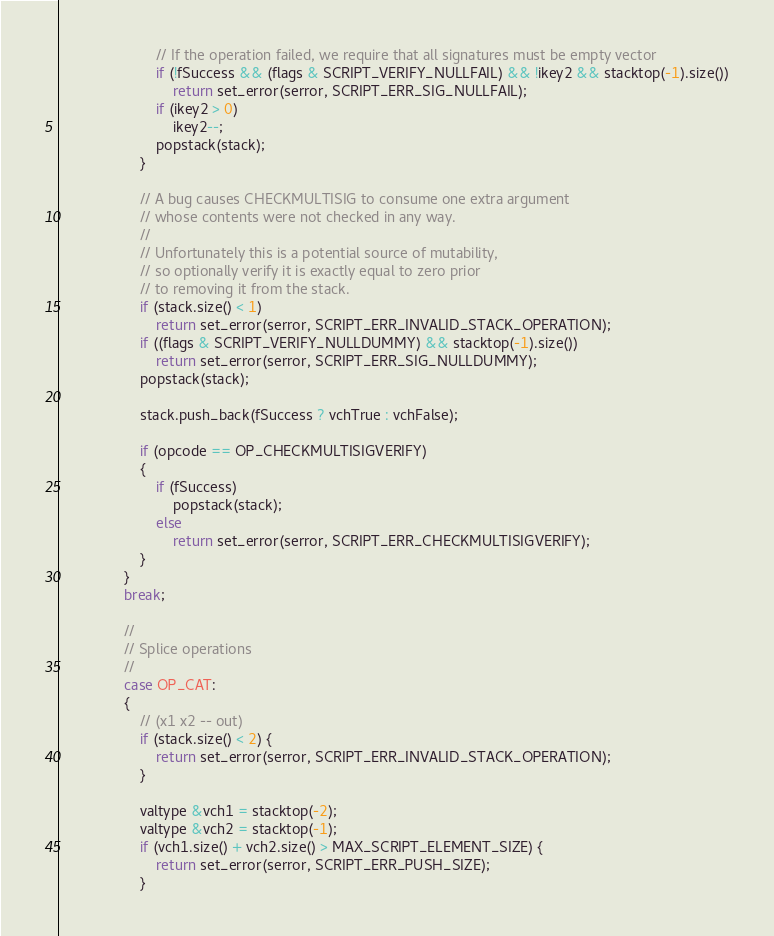Convert code to text. <code><loc_0><loc_0><loc_500><loc_500><_C++_>                        // If the operation failed, we require that all signatures must be empty vector
                        if (!fSuccess && (flags & SCRIPT_VERIFY_NULLFAIL) && !ikey2 && stacktop(-1).size())
                            return set_error(serror, SCRIPT_ERR_SIG_NULLFAIL);
                        if (ikey2 > 0)
                            ikey2--;
                        popstack(stack);
                    }

                    // A bug causes CHECKMULTISIG to consume one extra argument
                    // whose contents were not checked in any way.
                    //
                    // Unfortunately this is a potential source of mutability,
                    // so optionally verify it is exactly equal to zero prior
                    // to removing it from the stack.
                    if (stack.size() < 1)
                        return set_error(serror, SCRIPT_ERR_INVALID_STACK_OPERATION);
                    if ((flags & SCRIPT_VERIFY_NULLDUMMY) && stacktop(-1).size())
                        return set_error(serror, SCRIPT_ERR_SIG_NULLDUMMY);
                    popstack(stack);

                    stack.push_back(fSuccess ? vchTrue : vchFalse);

                    if (opcode == OP_CHECKMULTISIGVERIFY)
                    {
                        if (fSuccess)
                            popstack(stack);
                        else
                            return set_error(serror, SCRIPT_ERR_CHECKMULTISIGVERIFY);
                    }
                }
                break;

                //
                // Splice operations
                //
                case OP_CAT:
                {
                    // (x1 x2 -- out)
                    if (stack.size() < 2) {
                        return set_error(serror, SCRIPT_ERR_INVALID_STACK_OPERATION);
                    }

                    valtype &vch1 = stacktop(-2);
                    valtype &vch2 = stacktop(-1);
                    if (vch1.size() + vch2.size() > MAX_SCRIPT_ELEMENT_SIZE) {
                        return set_error(serror, SCRIPT_ERR_PUSH_SIZE);
                    }
</code> 